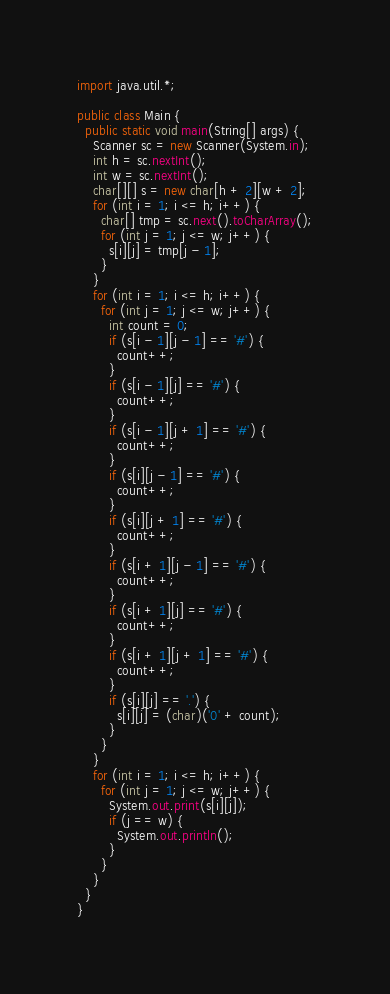<code> <loc_0><loc_0><loc_500><loc_500><_Java_>import java.util.*;

public class Main {
  public static void main(String[] args) {
    Scanner sc = new Scanner(System.in);
    int h = sc.nextInt();
    int w = sc.nextInt();
    char[][] s = new char[h + 2][w + 2];
    for (int i = 1; i <= h; i++) {
      char[] tmp = sc.next().toCharArray();
      for (int j = 1; j <= w; j++) {
        s[i][j] = tmp[j - 1];
      }
    }
    for (int i = 1; i <= h; i++) {
      for (int j = 1; j <= w; j++) {
        int count = 0;
        if (s[i - 1][j - 1] == '#') {
          count++;
        }
        if (s[i - 1][j] == '#') {
          count++;
        }
        if (s[i - 1][j + 1] == '#') {
          count++;
        }
        if (s[i][j - 1] == '#') {
          count++;
        }
        if (s[i][j + 1] == '#') {
          count++;
        }
        if (s[i + 1][j - 1] == '#') {
          count++;
        }
        if (s[i + 1][j] == '#') {
          count++;
        }
        if (s[i + 1][j + 1] == '#') {
          count++;
        }
        if (s[i][j] == '.') {
          s[i][j] = (char)('0' + count);
        }
      }
    }
    for (int i = 1; i <= h; i++) {
      for (int j = 1; j <= w; j++) {
        System.out.print(s[i][j]);
        if (j == w) {
          System.out.println();
        }
      }
    }
  }
}</code> 